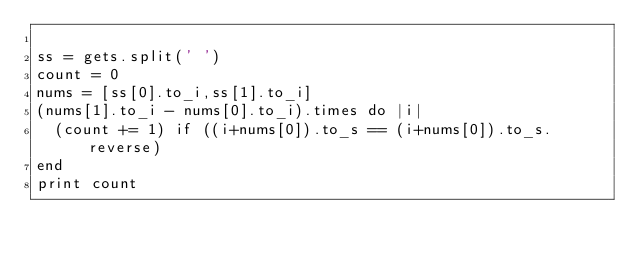Convert code to text. <code><loc_0><loc_0><loc_500><loc_500><_Ruby_>
ss = gets.split(' ')
count = 0
nums = [ss[0].to_i,ss[1].to_i]
(nums[1].to_i - nums[0].to_i).times do |i|
  (count += 1) if ((i+nums[0]).to_s == (i+nums[0]).to_s.reverse) 
end
print count</code> 